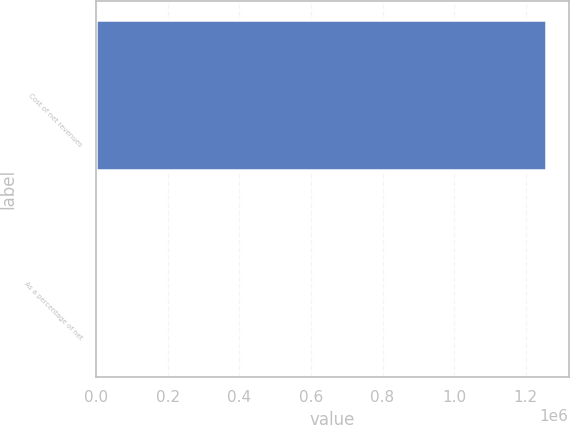Convert chart. <chart><loc_0><loc_0><loc_500><loc_500><bar_chart><fcel>Cost of net revenues<fcel>As a percentage of net<nl><fcel>1.25679e+06<fcel>21.1<nl></chart> 